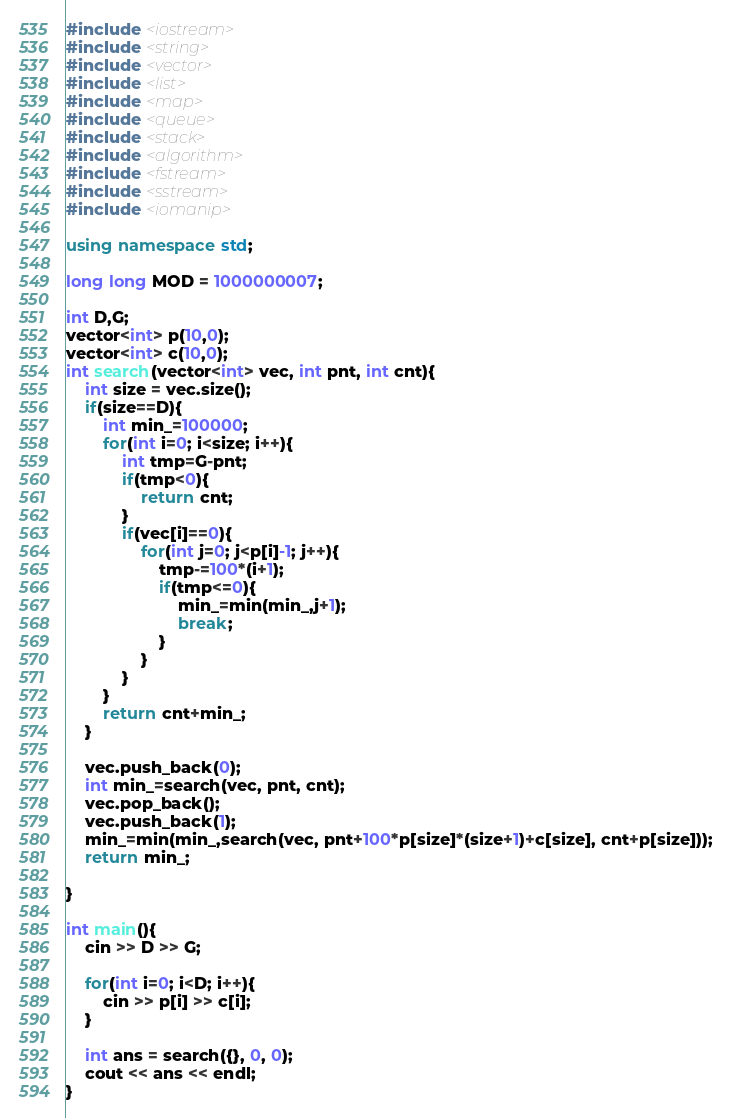Convert code to text. <code><loc_0><loc_0><loc_500><loc_500><_C++_>#include <iostream>
#include <string>
#include <vector>
#include <list>
#include <map>
#include <queue>
#include <stack>
#include <algorithm>
#include <fstream>
#include <sstream>
#include <iomanip>

using namespace std;

long long MOD = 1000000007;

int D,G;
vector<int> p(10,0);
vector<int> c(10,0);
int search(vector<int> vec, int pnt, int cnt){
    int size = vec.size();
    if(size==D){
        int min_=100000;
        for(int i=0; i<size; i++){
            int tmp=G-pnt;
            if(tmp<0){
                return cnt;
            }
            if(vec[i]==0){
                for(int j=0; j<p[i]-1; j++){
                    tmp-=100*(i+1);
                    if(tmp<=0){
                        min_=min(min_,j+1);
                        break;
                    }
                }
            }
        }
        return cnt+min_;
    }

    vec.push_back(0);
    int min_=search(vec, pnt, cnt);
    vec.pop_back();
    vec.push_back(1);
    min_=min(min_,search(vec, pnt+100*p[size]*(size+1)+c[size], cnt+p[size]));
    return min_;

}

int main(){
    cin >> D >> G;

    for(int i=0; i<D; i++){
        cin >> p[i] >> c[i];
    }

    int ans = search({}, 0, 0);
    cout << ans << endl;
}</code> 